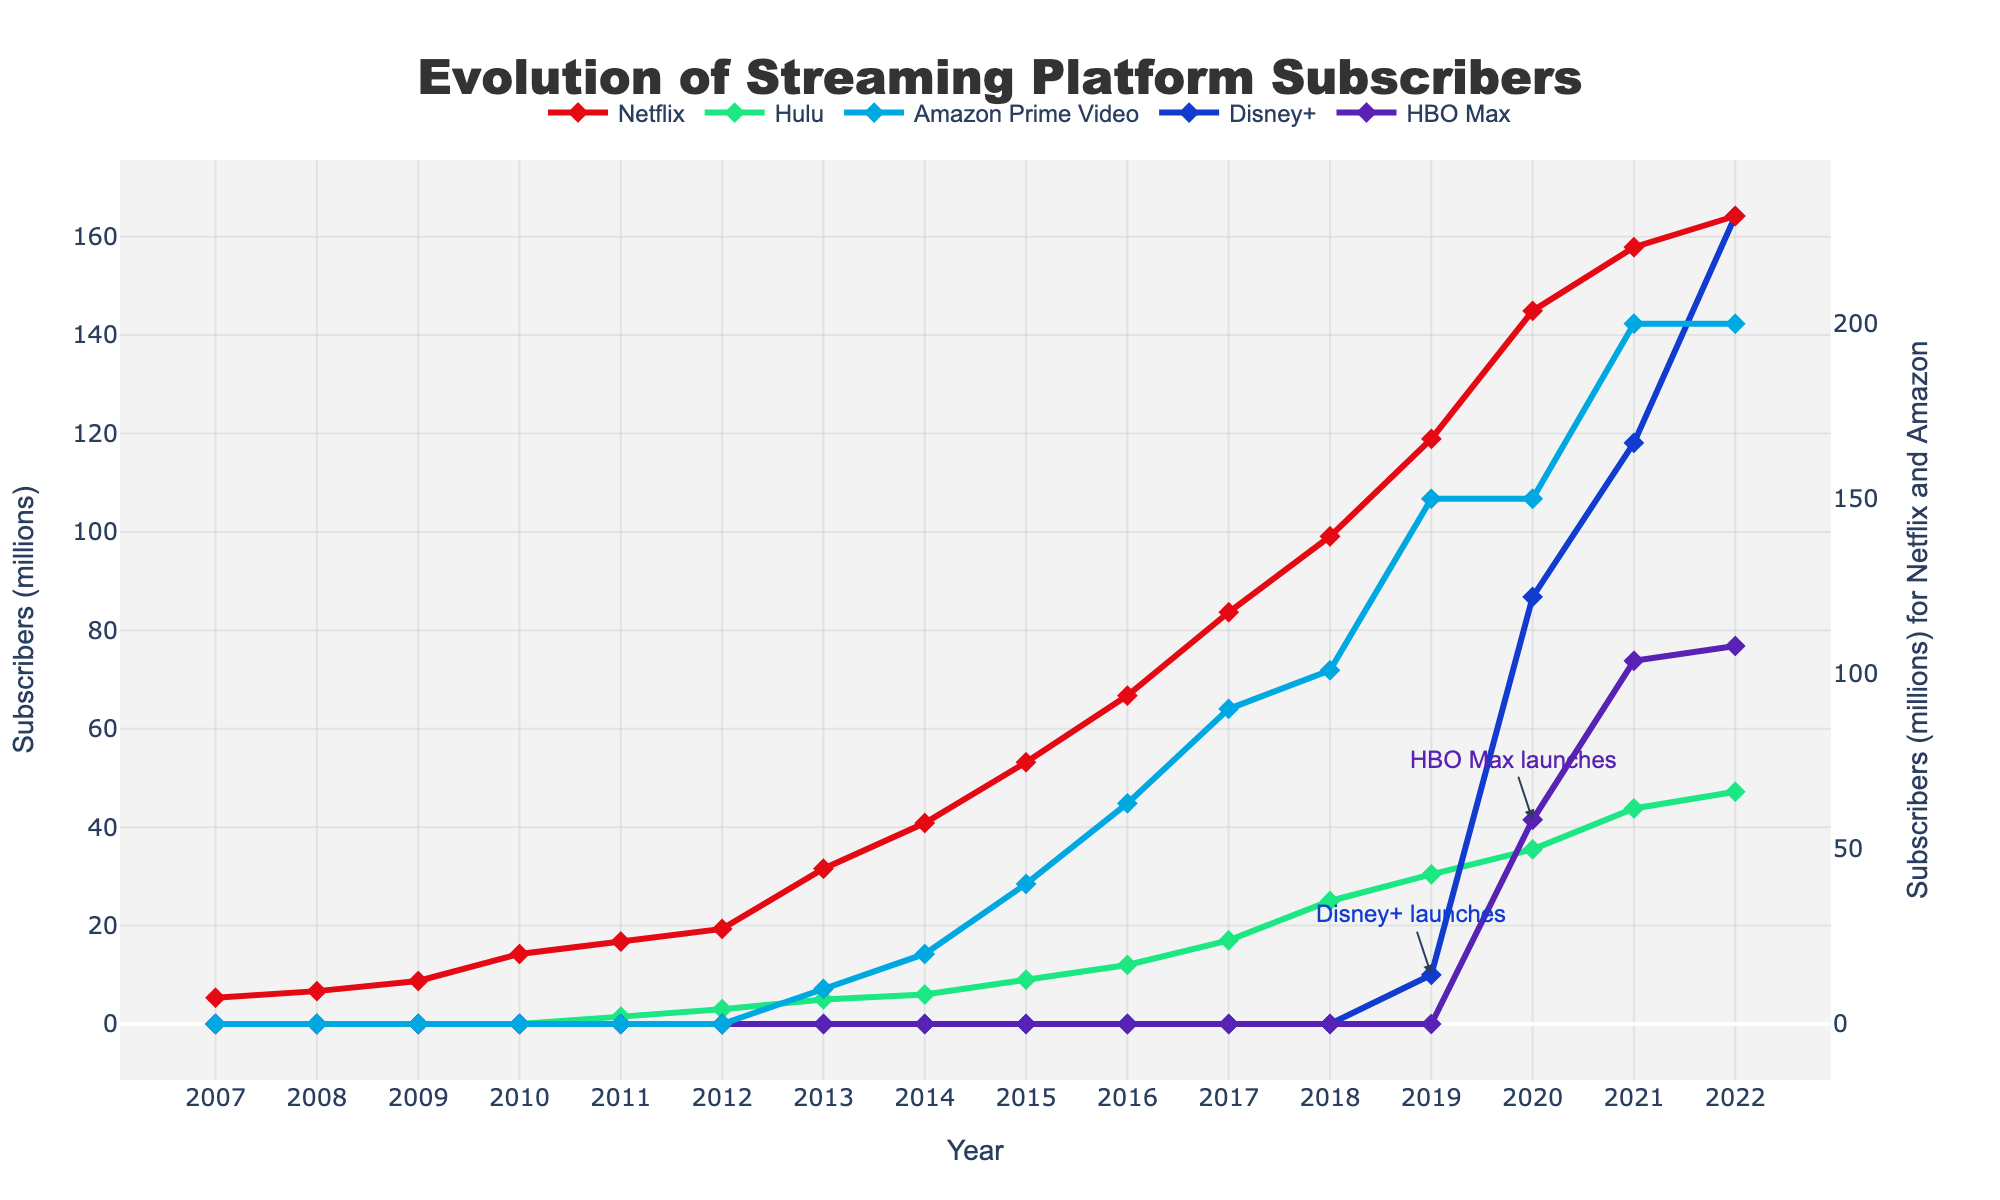How many total subscribers did Netflix and Amazon Prime Video have in 2021? First, find the number of subscribers Netflix had in 2021, which is 221.84 million. Next, find the number of subscribers Amazon Prime Video had in 2021, which is 200 million. Add these two numbers together: 221.84 + 200 = 421.84 million
Answer: 421.84 million Which platform had the highest increase in subscribers from 2020 to 2021? To determine the highest increase, we compare the difference in subscribers from 2020 to 2021 for each platform. 
- Netflix: 221.84 - 203.66 = 18.18 million
- Hulu: 43.8 - 35.5 = 8.3 million
- Amazon Prime Video: 200 - 150 = 50 million
- Disney+: 118.1 - 86.8 = 31.3 million
- HBO Max: 73.8 - 41.5 = 32.3 million
Amazon Prime Video had the highest increase.
Answer: Amazon Prime Video When did Disney+ surpass 100 million subscribers? Locate the point when Disney+ crosses the 100 million mark. According to the figure, this occurs in 2021 when Disney+ had 118.1 million subscribers, which is above 100 million.
Answer: 2021 How does the number of HBO Max's subscribers in 2021 compare to Hulu's in 2022? Find the number of subscribers for both platforms in the given years. HBO Max in 2021 had 73.8 million subscribers, while Hulu in 2022 had 47.2 million subscribers. Since 73.8 is greater than 47.2, HBO Max had more subscribers than Hulu in this comparison.
Answer: HBO Max had more subscribers Which platform had steady growth each year without any decline? Analyze the data for all platforms year over year. Netflix, Hulu, Amazon Prime Video, Disney+, and HBO Max all show increasing subscriber numbers each year without any decline. Thus, multiple platforms had steady growth each year.
Answer: Netflix, Hulu, Amazon Prime Video, Disney+, HBO Max 